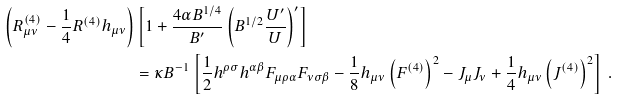Convert formula to latex. <formula><loc_0><loc_0><loc_500><loc_500>\left ( R ^ { ( 4 ) } _ { \mu \nu } - \frac { 1 } { 4 } R ^ { ( 4 ) } h _ { \mu \nu } \right ) & \left [ 1 + \frac { 4 \alpha B ^ { 1 / 4 } } { B ^ { \prime } } \left ( B ^ { 1 / 2 } \frac { U ^ { \prime } } { U } \right ) ^ { \prime } \right ] \\ & = \kappa B ^ { - 1 } \left [ \frac { 1 } { 2 } h ^ { \rho \sigma } h ^ { \alpha \beta } F _ { \mu \rho \alpha } F _ { \nu \sigma \beta } - \frac { 1 } { 8 } h _ { \mu \nu } \left ( F ^ { ( 4 ) } \right ) ^ { 2 } - J _ { \mu } J _ { \nu } + \frac { 1 } { 4 } h _ { \mu \nu } \left ( J ^ { ( 4 ) } \right ) ^ { 2 } \right ] \ .</formula> 